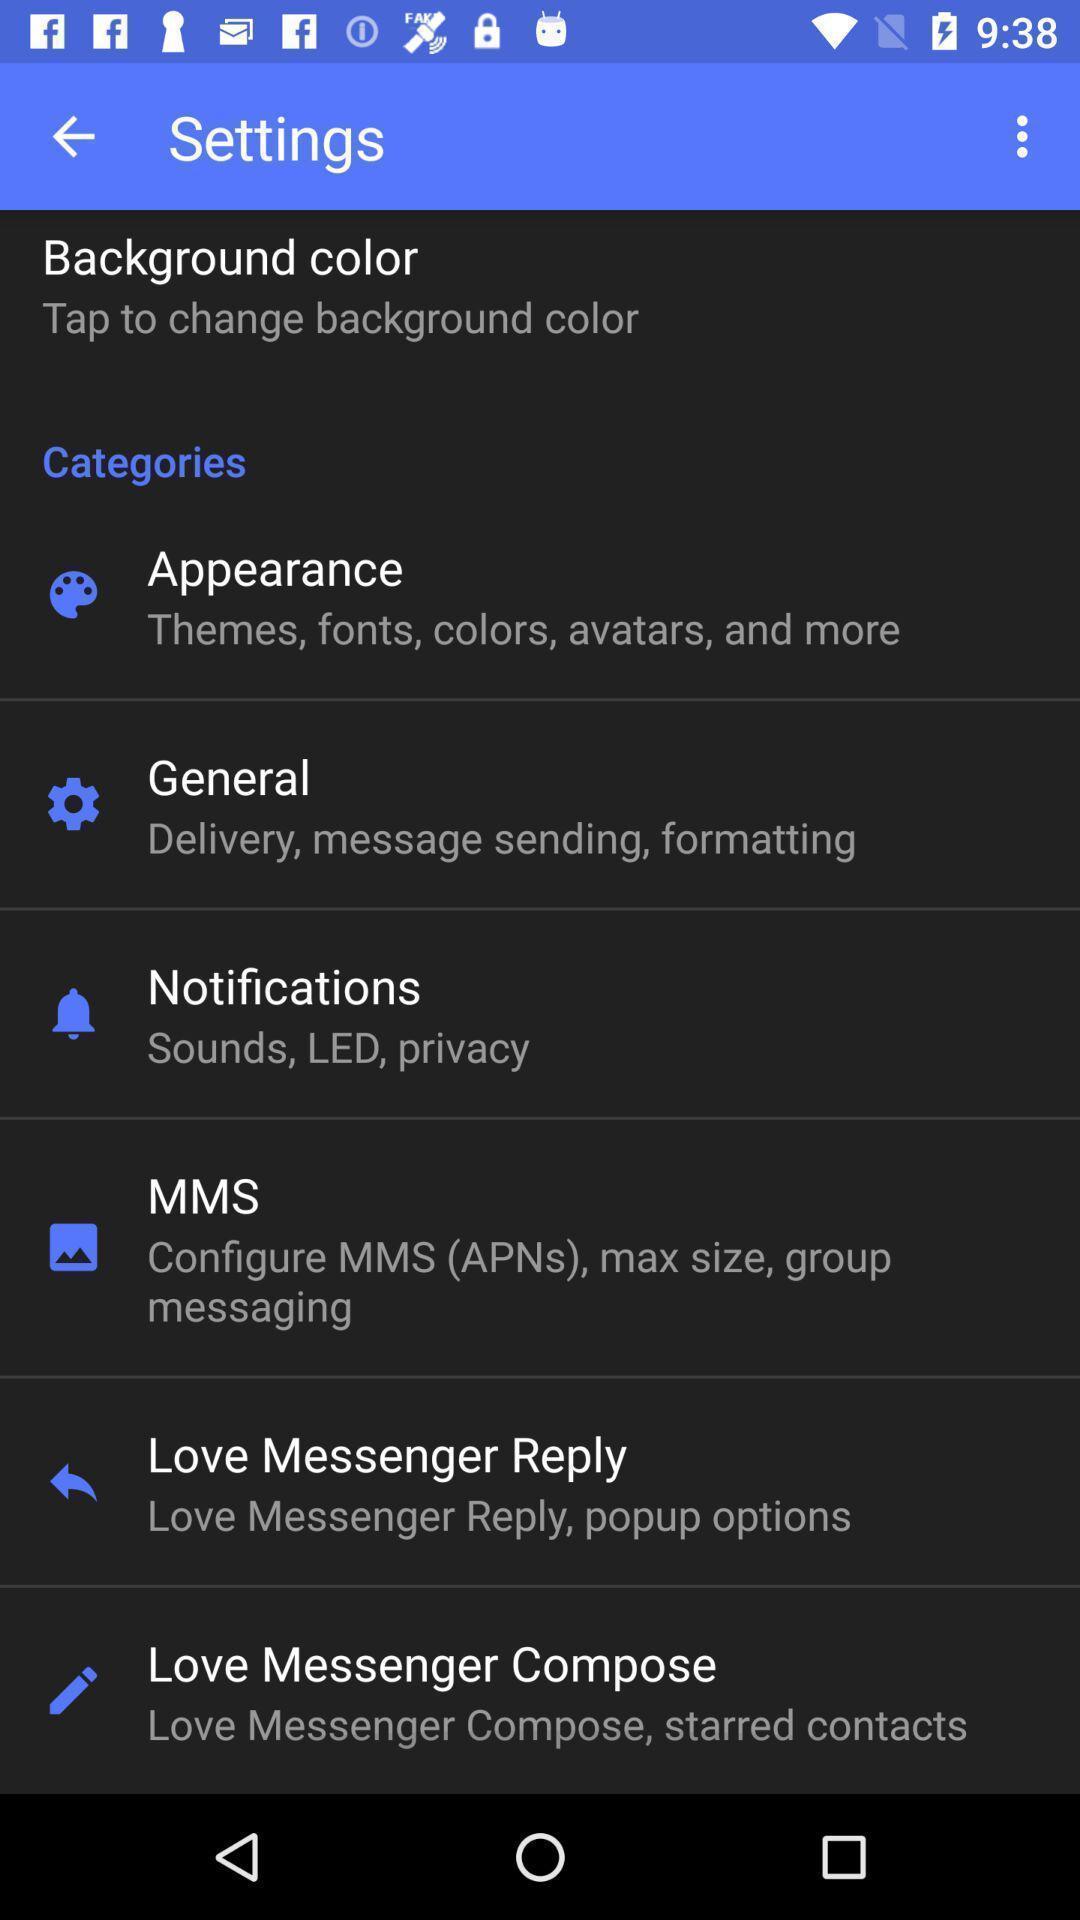Summarize the main components in this picture. Settings page. 